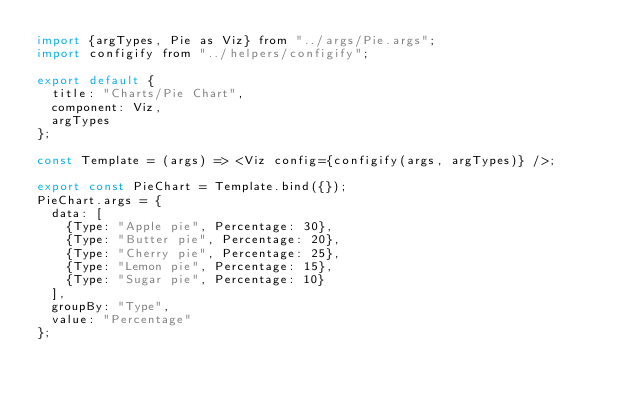<code> <loc_0><loc_0><loc_500><loc_500><_JavaScript_>import {argTypes, Pie as Viz} from "../args/Pie.args";
import configify from "../helpers/configify";

export default {
  title: "Charts/Pie Chart",
  component: Viz,
  argTypes
};

const Template = (args) => <Viz config={configify(args, argTypes)} />;

export const PieChart = Template.bind({});
PieChart.args = {
  data: [
    {Type: "Apple pie", Percentage: 30},
    {Type: "Butter pie", Percentage: 20},
    {Type: "Cherry pie", Percentage: 25},
    {Type: "Lemon pie", Percentage: 15},
    {Type: "Sugar pie", Percentage: 10}
  ],
  groupBy: "Type",
  value: "Percentage"
};
</code> 